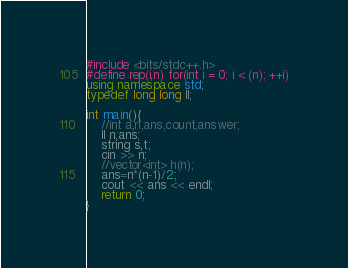Convert code to text. <code><loc_0><loc_0><loc_500><loc_500><_C++_>#include <bits/stdc++.h>
#define rep(i,n) for(int i = 0; i < (n); ++i)
using namespace std;
typedef long long ll;

int main(){
    //int a,n,ans,count,answer;
    ll n,ans;
    string s,t;
    cin >> n;
    //vector<int> h(n);
    ans=n*(n-1)/2;
    cout << ans << endl;
    return 0;
}
</code> 